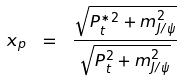<formula> <loc_0><loc_0><loc_500><loc_500>x _ { p } \ = \ \frac { \sqrt { P _ { t } ^ { { \ast } 2 } + m _ { J / \psi } ^ { 2 } } } { \sqrt { P _ { t } ^ { 2 } + m _ { J / \psi } ^ { 2 } } }</formula> 